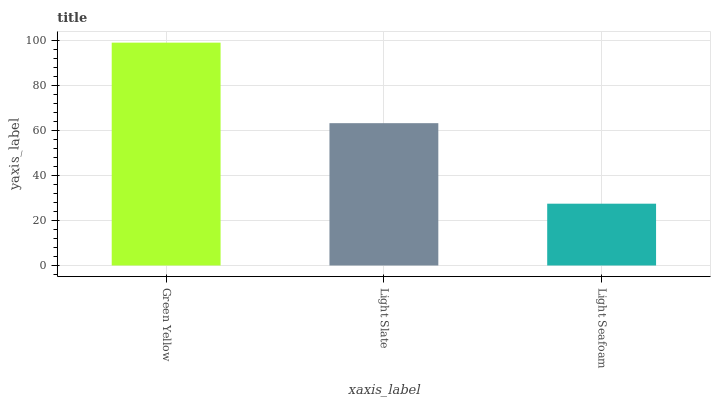Is Light Seafoam the minimum?
Answer yes or no. Yes. Is Green Yellow the maximum?
Answer yes or no. Yes. Is Light Slate the minimum?
Answer yes or no. No. Is Light Slate the maximum?
Answer yes or no. No. Is Green Yellow greater than Light Slate?
Answer yes or no. Yes. Is Light Slate less than Green Yellow?
Answer yes or no. Yes. Is Light Slate greater than Green Yellow?
Answer yes or no. No. Is Green Yellow less than Light Slate?
Answer yes or no. No. Is Light Slate the high median?
Answer yes or no. Yes. Is Light Slate the low median?
Answer yes or no. Yes. Is Light Seafoam the high median?
Answer yes or no. No. Is Green Yellow the low median?
Answer yes or no. No. 